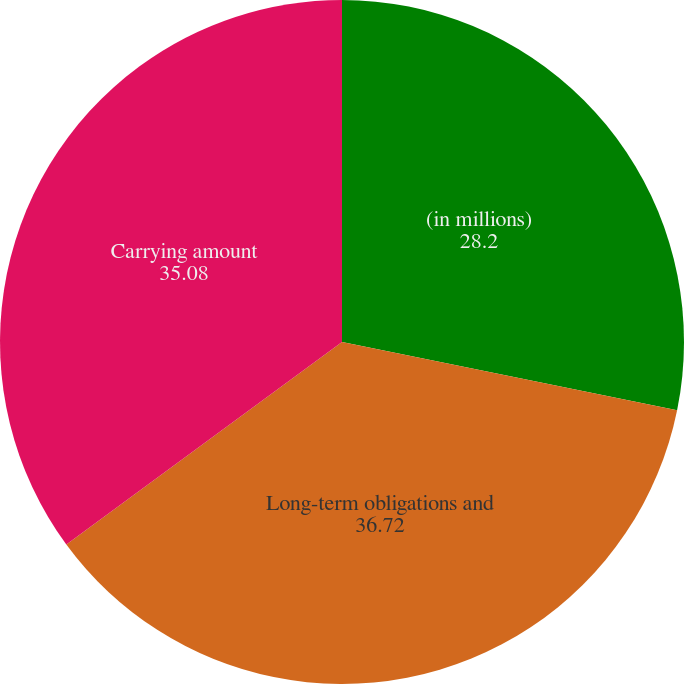Convert chart. <chart><loc_0><loc_0><loc_500><loc_500><pie_chart><fcel>(in millions)<fcel>Long-term obligations and<fcel>Carrying amount<nl><fcel>28.2%<fcel>36.72%<fcel>35.08%<nl></chart> 